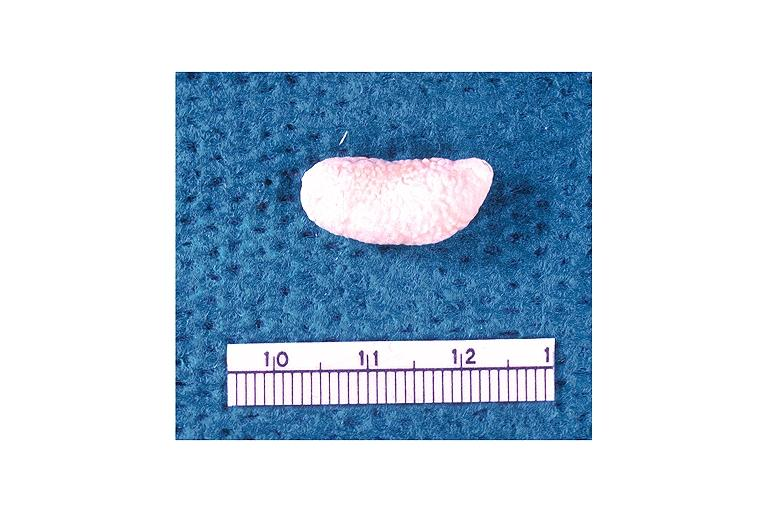does this image show sialolith?
Answer the question using a single word or phrase. Yes 